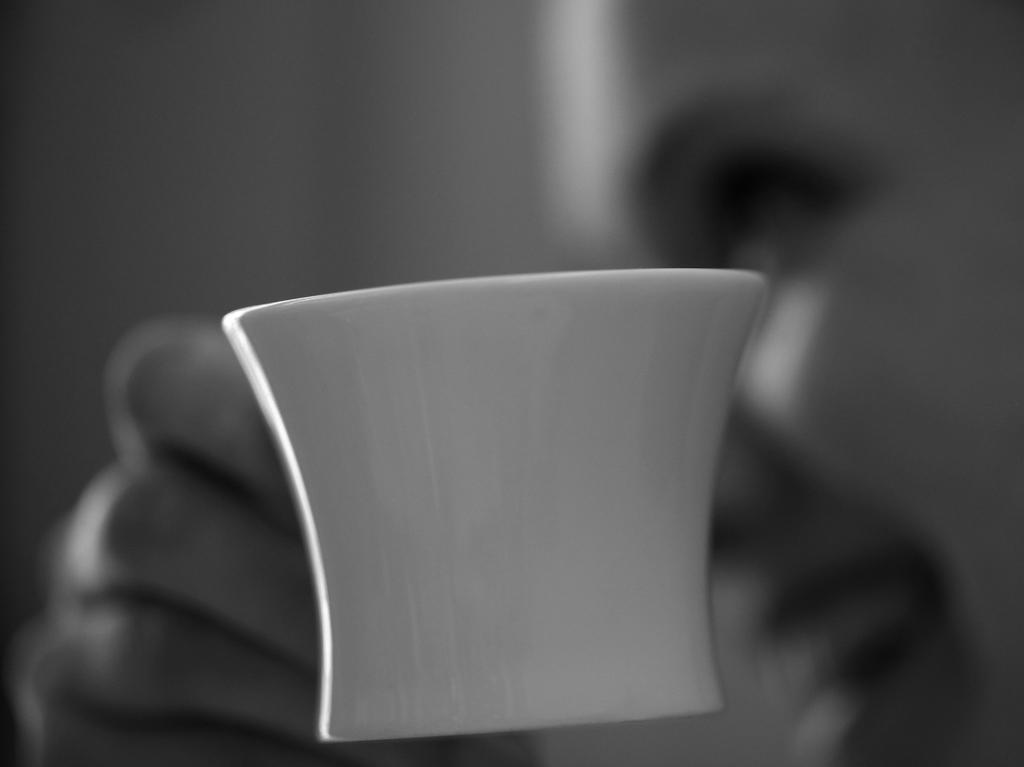What is present in the image? There is a person in the image. What is the person holding? The person is holding a cup. What type of bushes can be seen surrounding the person in the image? There are no bushes visible in the image; it only shows a person holding a cup. 